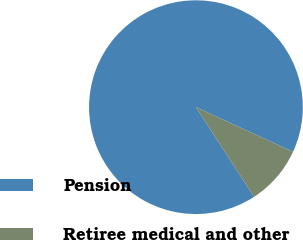Convert chart to OTSL. <chart><loc_0><loc_0><loc_500><loc_500><pie_chart><fcel>Pension<fcel>Retiree medical and other<nl><fcel>91.01%<fcel>8.99%<nl></chart> 